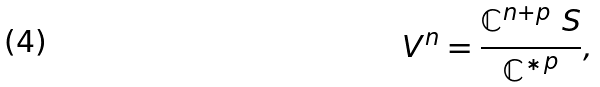<formula> <loc_0><loc_0><loc_500><loc_500>V ^ { n } = \frac { \mathbb { C } ^ { n + p } \ S } { { \mathbb { C } ^ { \ast } } ^ { p } } ,</formula> 